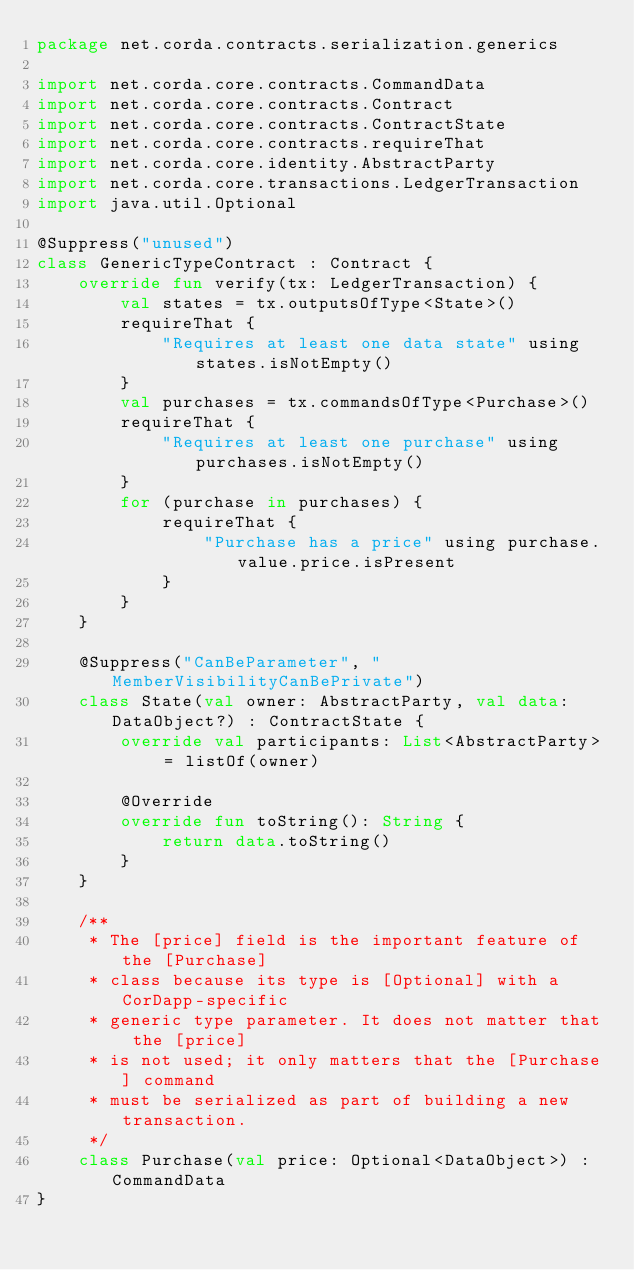Convert code to text. <code><loc_0><loc_0><loc_500><loc_500><_Kotlin_>package net.corda.contracts.serialization.generics

import net.corda.core.contracts.CommandData
import net.corda.core.contracts.Contract
import net.corda.core.contracts.ContractState
import net.corda.core.contracts.requireThat
import net.corda.core.identity.AbstractParty
import net.corda.core.transactions.LedgerTransaction
import java.util.Optional

@Suppress("unused")
class GenericTypeContract : Contract {
    override fun verify(tx: LedgerTransaction) {
        val states = tx.outputsOfType<State>()
        requireThat {
            "Requires at least one data state" using states.isNotEmpty()
        }
        val purchases = tx.commandsOfType<Purchase>()
        requireThat {
            "Requires at least one purchase" using purchases.isNotEmpty()
        }
        for (purchase in purchases) {
            requireThat {
                "Purchase has a price" using purchase.value.price.isPresent
            }
        }
    }

    @Suppress("CanBeParameter", "MemberVisibilityCanBePrivate")
    class State(val owner: AbstractParty, val data: DataObject?) : ContractState {
        override val participants: List<AbstractParty> = listOf(owner)

        @Override
        override fun toString(): String {
            return data.toString()
        }
    }

    /**
     * The [price] field is the important feature of the [Purchase]
     * class because its type is [Optional] with a CorDapp-specific
     * generic type parameter. It does not matter that the [price]
     * is not used; it only matters that the [Purchase] command
     * must be serialized as part of building a new transaction.
     */
    class Purchase(val price: Optional<DataObject>) : CommandData
}</code> 